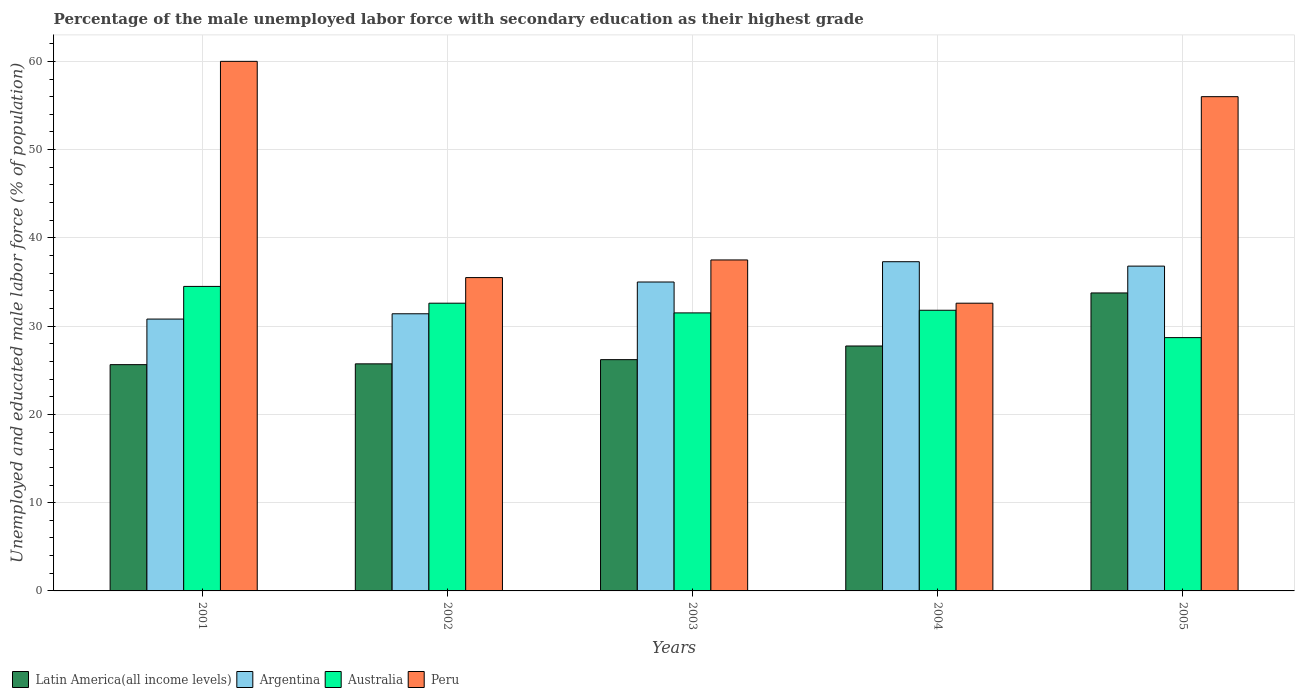How many groups of bars are there?
Offer a terse response. 5. How many bars are there on the 5th tick from the right?
Offer a very short reply. 4. What is the percentage of the unemployed male labor force with secondary education in Argentina in 2003?
Give a very brief answer. 35. Across all years, what is the maximum percentage of the unemployed male labor force with secondary education in Latin America(all income levels)?
Ensure brevity in your answer.  33.76. Across all years, what is the minimum percentage of the unemployed male labor force with secondary education in Argentina?
Your answer should be very brief. 30.8. In which year was the percentage of the unemployed male labor force with secondary education in Australia minimum?
Provide a short and direct response. 2005. What is the total percentage of the unemployed male labor force with secondary education in Peru in the graph?
Provide a succinct answer. 221.6. What is the difference between the percentage of the unemployed male labor force with secondary education in Peru in 2003 and that in 2005?
Offer a very short reply. -18.5. What is the difference between the percentage of the unemployed male labor force with secondary education in Australia in 2003 and the percentage of the unemployed male labor force with secondary education in Peru in 2002?
Keep it short and to the point. -4. What is the average percentage of the unemployed male labor force with secondary education in Peru per year?
Ensure brevity in your answer.  44.32. In the year 2002, what is the difference between the percentage of the unemployed male labor force with secondary education in Peru and percentage of the unemployed male labor force with secondary education in Argentina?
Your response must be concise. 4.1. In how many years, is the percentage of the unemployed male labor force with secondary education in Peru greater than 8 %?
Keep it short and to the point. 5. What is the ratio of the percentage of the unemployed male labor force with secondary education in Peru in 2004 to that in 2005?
Your answer should be compact. 0.58. Is the percentage of the unemployed male labor force with secondary education in Peru in 2002 less than that in 2005?
Give a very brief answer. Yes. What is the difference between the highest and the second highest percentage of the unemployed male labor force with secondary education in Peru?
Keep it short and to the point. 4. What is the difference between the highest and the lowest percentage of the unemployed male labor force with secondary education in Australia?
Your answer should be very brief. 5.8. Is it the case that in every year, the sum of the percentage of the unemployed male labor force with secondary education in Australia and percentage of the unemployed male labor force with secondary education in Latin America(all income levels) is greater than the percentage of the unemployed male labor force with secondary education in Peru?
Your answer should be compact. Yes. What is the difference between two consecutive major ticks on the Y-axis?
Make the answer very short. 10. Does the graph contain grids?
Keep it short and to the point. Yes. How many legend labels are there?
Your answer should be compact. 4. What is the title of the graph?
Offer a terse response. Percentage of the male unemployed labor force with secondary education as their highest grade. Does "Somalia" appear as one of the legend labels in the graph?
Provide a short and direct response. No. What is the label or title of the Y-axis?
Make the answer very short. Unemployed and educated male labor force (% of population). What is the Unemployed and educated male labor force (% of population) in Latin America(all income levels) in 2001?
Your answer should be compact. 25.64. What is the Unemployed and educated male labor force (% of population) in Argentina in 2001?
Offer a terse response. 30.8. What is the Unemployed and educated male labor force (% of population) in Australia in 2001?
Provide a succinct answer. 34.5. What is the Unemployed and educated male labor force (% of population) of Latin America(all income levels) in 2002?
Offer a terse response. 25.73. What is the Unemployed and educated male labor force (% of population) of Argentina in 2002?
Make the answer very short. 31.4. What is the Unemployed and educated male labor force (% of population) in Australia in 2002?
Your response must be concise. 32.6. What is the Unemployed and educated male labor force (% of population) of Peru in 2002?
Offer a terse response. 35.5. What is the Unemployed and educated male labor force (% of population) in Latin America(all income levels) in 2003?
Give a very brief answer. 26.2. What is the Unemployed and educated male labor force (% of population) in Argentina in 2003?
Offer a terse response. 35. What is the Unemployed and educated male labor force (% of population) in Australia in 2003?
Offer a terse response. 31.5. What is the Unemployed and educated male labor force (% of population) of Peru in 2003?
Keep it short and to the point. 37.5. What is the Unemployed and educated male labor force (% of population) in Latin America(all income levels) in 2004?
Offer a very short reply. 27.75. What is the Unemployed and educated male labor force (% of population) in Argentina in 2004?
Your response must be concise. 37.3. What is the Unemployed and educated male labor force (% of population) in Australia in 2004?
Give a very brief answer. 31.8. What is the Unemployed and educated male labor force (% of population) in Peru in 2004?
Give a very brief answer. 32.6. What is the Unemployed and educated male labor force (% of population) of Latin America(all income levels) in 2005?
Your answer should be compact. 33.76. What is the Unemployed and educated male labor force (% of population) in Argentina in 2005?
Your answer should be very brief. 36.8. What is the Unemployed and educated male labor force (% of population) in Australia in 2005?
Your answer should be compact. 28.7. What is the Unemployed and educated male labor force (% of population) in Peru in 2005?
Make the answer very short. 56. Across all years, what is the maximum Unemployed and educated male labor force (% of population) in Latin America(all income levels)?
Your answer should be very brief. 33.76. Across all years, what is the maximum Unemployed and educated male labor force (% of population) of Argentina?
Your answer should be compact. 37.3. Across all years, what is the maximum Unemployed and educated male labor force (% of population) in Australia?
Your answer should be very brief. 34.5. Across all years, what is the minimum Unemployed and educated male labor force (% of population) of Latin America(all income levels)?
Your answer should be very brief. 25.64. Across all years, what is the minimum Unemployed and educated male labor force (% of population) of Argentina?
Your response must be concise. 30.8. Across all years, what is the minimum Unemployed and educated male labor force (% of population) of Australia?
Offer a very short reply. 28.7. Across all years, what is the minimum Unemployed and educated male labor force (% of population) of Peru?
Offer a terse response. 32.6. What is the total Unemployed and educated male labor force (% of population) of Latin America(all income levels) in the graph?
Provide a succinct answer. 139.08. What is the total Unemployed and educated male labor force (% of population) in Argentina in the graph?
Provide a succinct answer. 171.3. What is the total Unemployed and educated male labor force (% of population) of Australia in the graph?
Ensure brevity in your answer.  159.1. What is the total Unemployed and educated male labor force (% of population) of Peru in the graph?
Keep it short and to the point. 221.6. What is the difference between the Unemployed and educated male labor force (% of population) of Latin America(all income levels) in 2001 and that in 2002?
Your response must be concise. -0.09. What is the difference between the Unemployed and educated male labor force (% of population) of Argentina in 2001 and that in 2002?
Provide a short and direct response. -0.6. What is the difference between the Unemployed and educated male labor force (% of population) of Australia in 2001 and that in 2002?
Give a very brief answer. 1.9. What is the difference between the Unemployed and educated male labor force (% of population) of Peru in 2001 and that in 2002?
Your response must be concise. 24.5. What is the difference between the Unemployed and educated male labor force (% of population) in Latin America(all income levels) in 2001 and that in 2003?
Your answer should be very brief. -0.57. What is the difference between the Unemployed and educated male labor force (% of population) of Argentina in 2001 and that in 2003?
Your response must be concise. -4.2. What is the difference between the Unemployed and educated male labor force (% of population) of Australia in 2001 and that in 2003?
Your response must be concise. 3. What is the difference between the Unemployed and educated male labor force (% of population) in Peru in 2001 and that in 2003?
Provide a succinct answer. 22.5. What is the difference between the Unemployed and educated male labor force (% of population) of Latin America(all income levels) in 2001 and that in 2004?
Keep it short and to the point. -2.11. What is the difference between the Unemployed and educated male labor force (% of population) in Argentina in 2001 and that in 2004?
Provide a succinct answer. -6.5. What is the difference between the Unemployed and educated male labor force (% of population) of Australia in 2001 and that in 2004?
Offer a very short reply. 2.7. What is the difference between the Unemployed and educated male labor force (% of population) of Peru in 2001 and that in 2004?
Your answer should be very brief. 27.4. What is the difference between the Unemployed and educated male labor force (% of population) of Latin America(all income levels) in 2001 and that in 2005?
Provide a succinct answer. -8.12. What is the difference between the Unemployed and educated male labor force (% of population) in Australia in 2001 and that in 2005?
Offer a very short reply. 5.8. What is the difference between the Unemployed and educated male labor force (% of population) in Latin America(all income levels) in 2002 and that in 2003?
Offer a terse response. -0.48. What is the difference between the Unemployed and educated male labor force (% of population) of Argentina in 2002 and that in 2003?
Provide a short and direct response. -3.6. What is the difference between the Unemployed and educated male labor force (% of population) in Peru in 2002 and that in 2003?
Make the answer very short. -2. What is the difference between the Unemployed and educated male labor force (% of population) of Latin America(all income levels) in 2002 and that in 2004?
Your response must be concise. -2.02. What is the difference between the Unemployed and educated male labor force (% of population) in Australia in 2002 and that in 2004?
Provide a short and direct response. 0.8. What is the difference between the Unemployed and educated male labor force (% of population) of Latin America(all income levels) in 2002 and that in 2005?
Give a very brief answer. -8.03. What is the difference between the Unemployed and educated male labor force (% of population) in Peru in 2002 and that in 2005?
Provide a succinct answer. -20.5. What is the difference between the Unemployed and educated male labor force (% of population) in Latin America(all income levels) in 2003 and that in 2004?
Offer a very short reply. -1.55. What is the difference between the Unemployed and educated male labor force (% of population) of Peru in 2003 and that in 2004?
Keep it short and to the point. 4.9. What is the difference between the Unemployed and educated male labor force (% of population) of Latin America(all income levels) in 2003 and that in 2005?
Your answer should be very brief. -7.56. What is the difference between the Unemployed and educated male labor force (% of population) of Peru in 2003 and that in 2005?
Your answer should be compact. -18.5. What is the difference between the Unemployed and educated male labor force (% of population) in Latin America(all income levels) in 2004 and that in 2005?
Keep it short and to the point. -6.01. What is the difference between the Unemployed and educated male labor force (% of population) of Argentina in 2004 and that in 2005?
Your answer should be very brief. 0.5. What is the difference between the Unemployed and educated male labor force (% of population) in Australia in 2004 and that in 2005?
Offer a very short reply. 3.1. What is the difference between the Unemployed and educated male labor force (% of population) of Peru in 2004 and that in 2005?
Provide a short and direct response. -23.4. What is the difference between the Unemployed and educated male labor force (% of population) in Latin America(all income levels) in 2001 and the Unemployed and educated male labor force (% of population) in Argentina in 2002?
Provide a short and direct response. -5.76. What is the difference between the Unemployed and educated male labor force (% of population) of Latin America(all income levels) in 2001 and the Unemployed and educated male labor force (% of population) of Australia in 2002?
Offer a terse response. -6.96. What is the difference between the Unemployed and educated male labor force (% of population) of Latin America(all income levels) in 2001 and the Unemployed and educated male labor force (% of population) of Peru in 2002?
Ensure brevity in your answer.  -9.86. What is the difference between the Unemployed and educated male labor force (% of population) in Argentina in 2001 and the Unemployed and educated male labor force (% of population) in Australia in 2002?
Offer a terse response. -1.8. What is the difference between the Unemployed and educated male labor force (% of population) in Australia in 2001 and the Unemployed and educated male labor force (% of population) in Peru in 2002?
Your answer should be compact. -1. What is the difference between the Unemployed and educated male labor force (% of population) in Latin America(all income levels) in 2001 and the Unemployed and educated male labor force (% of population) in Argentina in 2003?
Ensure brevity in your answer.  -9.36. What is the difference between the Unemployed and educated male labor force (% of population) of Latin America(all income levels) in 2001 and the Unemployed and educated male labor force (% of population) of Australia in 2003?
Provide a short and direct response. -5.86. What is the difference between the Unemployed and educated male labor force (% of population) of Latin America(all income levels) in 2001 and the Unemployed and educated male labor force (% of population) of Peru in 2003?
Your response must be concise. -11.86. What is the difference between the Unemployed and educated male labor force (% of population) in Argentina in 2001 and the Unemployed and educated male labor force (% of population) in Peru in 2003?
Keep it short and to the point. -6.7. What is the difference between the Unemployed and educated male labor force (% of population) of Latin America(all income levels) in 2001 and the Unemployed and educated male labor force (% of population) of Argentina in 2004?
Give a very brief answer. -11.66. What is the difference between the Unemployed and educated male labor force (% of population) of Latin America(all income levels) in 2001 and the Unemployed and educated male labor force (% of population) of Australia in 2004?
Provide a short and direct response. -6.16. What is the difference between the Unemployed and educated male labor force (% of population) in Latin America(all income levels) in 2001 and the Unemployed and educated male labor force (% of population) in Peru in 2004?
Provide a succinct answer. -6.96. What is the difference between the Unemployed and educated male labor force (% of population) of Argentina in 2001 and the Unemployed and educated male labor force (% of population) of Australia in 2004?
Give a very brief answer. -1. What is the difference between the Unemployed and educated male labor force (% of population) in Argentina in 2001 and the Unemployed and educated male labor force (% of population) in Peru in 2004?
Provide a short and direct response. -1.8. What is the difference between the Unemployed and educated male labor force (% of population) of Latin America(all income levels) in 2001 and the Unemployed and educated male labor force (% of population) of Argentina in 2005?
Keep it short and to the point. -11.16. What is the difference between the Unemployed and educated male labor force (% of population) of Latin America(all income levels) in 2001 and the Unemployed and educated male labor force (% of population) of Australia in 2005?
Provide a short and direct response. -3.06. What is the difference between the Unemployed and educated male labor force (% of population) in Latin America(all income levels) in 2001 and the Unemployed and educated male labor force (% of population) in Peru in 2005?
Your response must be concise. -30.36. What is the difference between the Unemployed and educated male labor force (% of population) in Argentina in 2001 and the Unemployed and educated male labor force (% of population) in Peru in 2005?
Your response must be concise. -25.2. What is the difference between the Unemployed and educated male labor force (% of population) of Australia in 2001 and the Unemployed and educated male labor force (% of population) of Peru in 2005?
Provide a short and direct response. -21.5. What is the difference between the Unemployed and educated male labor force (% of population) of Latin America(all income levels) in 2002 and the Unemployed and educated male labor force (% of population) of Argentina in 2003?
Offer a terse response. -9.27. What is the difference between the Unemployed and educated male labor force (% of population) of Latin America(all income levels) in 2002 and the Unemployed and educated male labor force (% of population) of Australia in 2003?
Provide a short and direct response. -5.77. What is the difference between the Unemployed and educated male labor force (% of population) in Latin America(all income levels) in 2002 and the Unemployed and educated male labor force (% of population) in Peru in 2003?
Offer a very short reply. -11.77. What is the difference between the Unemployed and educated male labor force (% of population) of Australia in 2002 and the Unemployed and educated male labor force (% of population) of Peru in 2003?
Keep it short and to the point. -4.9. What is the difference between the Unemployed and educated male labor force (% of population) in Latin America(all income levels) in 2002 and the Unemployed and educated male labor force (% of population) in Argentina in 2004?
Keep it short and to the point. -11.57. What is the difference between the Unemployed and educated male labor force (% of population) of Latin America(all income levels) in 2002 and the Unemployed and educated male labor force (% of population) of Australia in 2004?
Make the answer very short. -6.07. What is the difference between the Unemployed and educated male labor force (% of population) in Latin America(all income levels) in 2002 and the Unemployed and educated male labor force (% of population) in Peru in 2004?
Your response must be concise. -6.87. What is the difference between the Unemployed and educated male labor force (% of population) of Argentina in 2002 and the Unemployed and educated male labor force (% of population) of Australia in 2004?
Give a very brief answer. -0.4. What is the difference between the Unemployed and educated male labor force (% of population) of Australia in 2002 and the Unemployed and educated male labor force (% of population) of Peru in 2004?
Ensure brevity in your answer.  0. What is the difference between the Unemployed and educated male labor force (% of population) in Latin America(all income levels) in 2002 and the Unemployed and educated male labor force (% of population) in Argentina in 2005?
Make the answer very short. -11.07. What is the difference between the Unemployed and educated male labor force (% of population) in Latin America(all income levels) in 2002 and the Unemployed and educated male labor force (% of population) in Australia in 2005?
Offer a very short reply. -2.97. What is the difference between the Unemployed and educated male labor force (% of population) in Latin America(all income levels) in 2002 and the Unemployed and educated male labor force (% of population) in Peru in 2005?
Make the answer very short. -30.27. What is the difference between the Unemployed and educated male labor force (% of population) of Argentina in 2002 and the Unemployed and educated male labor force (% of population) of Peru in 2005?
Make the answer very short. -24.6. What is the difference between the Unemployed and educated male labor force (% of population) in Australia in 2002 and the Unemployed and educated male labor force (% of population) in Peru in 2005?
Provide a short and direct response. -23.4. What is the difference between the Unemployed and educated male labor force (% of population) of Latin America(all income levels) in 2003 and the Unemployed and educated male labor force (% of population) of Argentina in 2004?
Your answer should be compact. -11.1. What is the difference between the Unemployed and educated male labor force (% of population) of Latin America(all income levels) in 2003 and the Unemployed and educated male labor force (% of population) of Australia in 2004?
Your response must be concise. -5.6. What is the difference between the Unemployed and educated male labor force (% of population) in Latin America(all income levels) in 2003 and the Unemployed and educated male labor force (% of population) in Peru in 2004?
Your answer should be very brief. -6.4. What is the difference between the Unemployed and educated male labor force (% of population) in Latin America(all income levels) in 2003 and the Unemployed and educated male labor force (% of population) in Argentina in 2005?
Keep it short and to the point. -10.6. What is the difference between the Unemployed and educated male labor force (% of population) of Latin America(all income levels) in 2003 and the Unemployed and educated male labor force (% of population) of Australia in 2005?
Give a very brief answer. -2.5. What is the difference between the Unemployed and educated male labor force (% of population) in Latin America(all income levels) in 2003 and the Unemployed and educated male labor force (% of population) in Peru in 2005?
Keep it short and to the point. -29.8. What is the difference between the Unemployed and educated male labor force (% of population) of Argentina in 2003 and the Unemployed and educated male labor force (% of population) of Australia in 2005?
Provide a short and direct response. 6.3. What is the difference between the Unemployed and educated male labor force (% of population) in Australia in 2003 and the Unemployed and educated male labor force (% of population) in Peru in 2005?
Your answer should be compact. -24.5. What is the difference between the Unemployed and educated male labor force (% of population) of Latin America(all income levels) in 2004 and the Unemployed and educated male labor force (% of population) of Argentina in 2005?
Offer a very short reply. -9.05. What is the difference between the Unemployed and educated male labor force (% of population) of Latin America(all income levels) in 2004 and the Unemployed and educated male labor force (% of population) of Australia in 2005?
Ensure brevity in your answer.  -0.95. What is the difference between the Unemployed and educated male labor force (% of population) in Latin America(all income levels) in 2004 and the Unemployed and educated male labor force (% of population) in Peru in 2005?
Ensure brevity in your answer.  -28.25. What is the difference between the Unemployed and educated male labor force (% of population) of Argentina in 2004 and the Unemployed and educated male labor force (% of population) of Peru in 2005?
Give a very brief answer. -18.7. What is the difference between the Unemployed and educated male labor force (% of population) of Australia in 2004 and the Unemployed and educated male labor force (% of population) of Peru in 2005?
Your answer should be compact. -24.2. What is the average Unemployed and educated male labor force (% of population) in Latin America(all income levels) per year?
Make the answer very short. 27.82. What is the average Unemployed and educated male labor force (% of population) in Argentina per year?
Your response must be concise. 34.26. What is the average Unemployed and educated male labor force (% of population) in Australia per year?
Offer a terse response. 31.82. What is the average Unemployed and educated male labor force (% of population) in Peru per year?
Provide a short and direct response. 44.32. In the year 2001, what is the difference between the Unemployed and educated male labor force (% of population) of Latin America(all income levels) and Unemployed and educated male labor force (% of population) of Argentina?
Offer a terse response. -5.16. In the year 2001, what is the difference between the Unemployed and educated male labor force (% of population) of Latin America(all income levels) and Unemployed and educated male labor force (% of population) of Australia?
Make the answer very short. -8.86. In the year 2001, what is the difference between the Unemployed and educated male labor force (% of population) of Latin America(all income levels) and Unemployed and educated male labor force (% of population) of Peru?
Your answer should be compact. -34.36. In the year 2001, what is the difference between the Unemployed and educated male labor force (% of population) in Argentina and Unemployed and educated male labor force (% of population) in Peru?
Your answer should be compact. -29.2. In the year 2001, what is the difference between the Unemployed and educated male labor force (% of population) of Australia and Unemployed and educated male labor force (% of population) of Peru?
Your answer should be very brief. -25.5. In the year 2002, what is the difference between the Unemployed and educated male labor force (% of population) of Latin America(all income levels) and Unemployed and educated male labor force (% of population) of Argentina?
Your response must be concise. -5.67. In the year 2002, what is the difference between the Unemployed and educated male labor force (% of population) of Latin America(all income levels) and Unemployed and educated male labor force (% of population) of Australia?
Keep it short and to the point. -6.87. In the year 2002, what is the difference between the Unemployed and educated male labor force (% of population) of Latin America(all income levels) and Unemployed and educated male labor force (% of population) of Peru?
Make the answer very short. -9.77. In the year 2002, what is the difference between the Unemployed and educated male labor force (% of population) of Argentina and Unemployed and educated male labor force (% of population) of Australia?
Offer a terse response. -1.2. In the year 2003, what is the difference between the Unemployed and educated male labor force (% of population) in Latin America(all income levels) and Unemployed and educated male labor force (% of population) in Argentina?
Your answer should be compact. -8.8. In the year 2003, what is the difference between the Unemployed and educated male labor force (% of population) of Latin America(all income levels) and Unemployed and educated male labor force (% of population) of Australia?
Make the answer very short. -5.3. In the year 2003, what is the difference between the Unemployed and educated male labor force (% of population) in Latin America(all income levels) and Unemployed and educated male labor force (% of population) in Peru?
Your answer should be very brief. -11.3. In the year 2003, what is the difference between the Unemployed and educated male labor force (% of population) of Argentina and Unemployed and educated male labor force (% of population) of Australia?
Make the answer very short. 3.5. In the year 2003, what is the difference between the Unemployed and educated male labor force (% of population) in Argentina and Unemployed and educated male labor force (% of population) in Peru?
Offer a very short reply. -2.5. In the year 2004, what is the difference between the Unemployed and educated male labor force (% of population) in Latin America(all income levels) and Unemployed and educated male labor force (% of population) in Argentina?
Your answer should be very brief. -9.55. In the year 2004, what is the difference between the Unemployed and educated male labor force (% of population) in Latin America(all income levels) and Unemployed and educated male labor force (% of population) in Australia?
Give a very brief answer. -4.05. In the year 2004, what is the difference between the Unemployed and educated male labor force (% of population) in Latin America(all income levels) and Unemployed and educated male labor force (% of population) in Peru?
Your answer should be very brief. -4.85. In the year 2004, what is the difference between the Unemployed and educated male labor force (% of population) in Argentina and Unemployed and educated male labor force (% of population) in Australia?
Give a very brief answer. 5.5. In the year 2004, what is the difference between the Unemployed and educated male labor force (% of population) of Argentina and Unemployed and educated male labor force (% of population) of Peru?
Offer a terse response. 4.7. In the year 2005, what is the difference between the Unemployed and educated male labor force (% of population) of Latin America(all income levels) and Unemployed and educated male labor force (% of population) of Argentina?
Offer a very short reply. -3.04. In the year 2005, what is the difference between the Unemployed and educated male labor force (% of population) in Latin America(all income levels) and Unemployed and educated male labor force (% of population) in Australia?
Offer a terse response. 5.06. In the year 2005, what is the difference between the Unemployed and educated male labor force (% of population) of Latin America(all income levels) and Unemployed and educated male labor force (% of population) of Peru?
Give a very brief answer. -22.24. In the year 2005, what is the difference between the Unemployed and educated male labor force (% of population) of Argentina and Unemployed and educated male labor force (% of population) of Peru?
Your response must be concise. -19.2. In the year 2005, what is the difference between the Unemployed and educated male labor force (% of population) in Australia and Unemployed and educated male labor force (% of population) in Peru?
Your response must be concise. -27.3. What is the ratio of the Unemployed and educated male labor force (% of population) of Argentina in 2001 to that in 2002?
Your response must be concise. 0.98. What is the ratio of the Unemployed and educated male labor force (% of population) of Australia in 2001 to that in 2002?
Your answer should be very brief. 1.06. What is the ratio of the Unemployed and educated male labor force (% of population) of Peru in 2001 to that in 2002?
Make the answer very short. 1.69. What is the ratio of the Unemployed and educated male labor force (% of population) of Latin America(all income levels) in 2001 to that in 2003?
Make the answer very short. 0.98. What is the ratio of the Unemployed and educated male labor force (% of population) of Australia in 2001 to that in 2003?
Your response must be concise. 1.1. What is the ratio of the Unemployed and educated male labor force (% of population) of Latin America(all income levels) in 2001 to that in 2004?
Provide a succinct answer. 0.92. What is the ratio of the Unemployed and educated male labor force (% of population) in Argentina in 2001 to that in 2004?
Give a very brief answer. 0.83. What is the ratio of the Unemployed and educated male labor force (% of population) in Australia in 2001 to that in 2004?
Ensure brevity in your answer.  1.08. What is the ratio of the Unemployed and educated male labor force (% of population) in Peru in 2001 to that in 2004?
Your answer should be very brief. 1.84. What is the ratio of the Unemployed and educated male labor force (% of population) of Latin America(all income levels) in 2001 to that in 2005?
Your answer should be very brief. 0.76. What is the ratio of the Unemployed and educated male labor force (% of population) of Argentina in 2001 to that in 2005?
Offer a terse response. 0.84. What is the ratio of the Unemployed and educated male labor force (% of population) of Australia in 2001 to that in 2005?
Make the answer very short. 1.2. What is the ratio of the Unemployed and educated male labor force (% of population) of Peru in 2001 to that in 2005?
Your answer should be very brief. 1.07. What is the ratio of the Unemployed and educated male labor force (% of population) of Latin America(all income levels) in 2002 to that in 2003?
Ensure brevity in your answer.  0.98. What is the ratio of the Unemployed and educated male labor force (% of population) in Argentina in 2002 to that in 2003?
Your response must be concise. 0.9. What is the ratio of the Unemployed and educated male labor force (% of population) in Australia in 2002 to that in 2003?
Provide a short and direct response. 1.03. What is the ratio of the Unemployed and educated male labor force (% of population) of Peru in 2002 to that in 2003?
Ensure brevity in your answer.  0.95. What is the ratio of the Unemployed and educated male labor force (% of population) in Latin America(all income levels) in 2002 to that in 2004?
Give a very brief answer. 0.93. What is the ratio of the Unemployed and educated male labor force (% of population) of Argentina in 2002 to that in 2004?
Ensure brevity in your answer.  0.84. What is the ratio of the Unemployed and educated male labor force (% of population) of Australia in 2002 to that in 2004?
Make the answer very short. 1.03. What is the ratio of the Unemployed and educated male labor force (% of population) of Peru in 2002 to that in 2004?
Offer a very short reply. 1.09. What is the ratio of the Unemployed and educated male labor force (% of population) in Latin America(all income levels) in 2002 to that in 2005?
Your response must be concise. 0.76. What is the ratio of the Unemployed and educated male labor force (% of population) of Argentina in 2002 to that in 2005?
Your answer should be compact. 0.85. What is the ratio of the Unemployed and educated male labor force (% of population) of Australia in 2002 to that in 2005?
Provide a succinct answer. 1.14. What is the ratio of the Unemployed and educated male labor force (% of population) of Peru in 2002 to that in 2005?
Keep it short and to the point. 0.63. What is the ratio of the Unemployed and educated male labor force (% of population) in Latin America(all income levels) in 2003 to that in 2004?
Provide a succinct answer. 0.94. What is the ratio of the Unemployed and educated male labor force (% of population) in Argentina in 2003 to that in 2004?
Your answer should be very brief. 0.94. What is the ratio of the Unemployed and educated male labor force (% of population) in Australia in 2003 to that in 2004?
Provide a short and direct response. 0.99. What is the ratio of the Unemployed and educated male labor force (% of population) of Peru in 2003 to that in 2004?
Your answer should be compact. 1.15. What is the ratio of the Unemployed and educated male labor force (% of population) of Latin America(all income levels) in 2003 to that in 2005?
Your response must be concise. 0.78. What is the ratio of the Unemployed and educated male labor force (% of population) in Argentina in 2003 to that in 2005?
Ensure brevity in your answer.  0.95. What is the ratio of the Unemployed and educated male labor force (% of population) of Australia in 2003 to that in 2005?
Offer a very short reply. 1.1. What is the ratio of the Unemployed and educated male labor force (% of population) in Peru in 2003 to that in 2005?
Provide a succinct answer. 0.67. What is the ratio of the Unemployed and educated male labor force (% of population) in Latin America(all income levels) in 2004 to that in 2005?
Ensure brevity in your answer.  0.82. What is the ratio of the Unemployed and educated male labor force (% of population) in Argentina in 2004 to that in 2005?
Your answer should be very brief. 1.01. What is the ratio of the Unemployed and educated male labor force (% of population) of Australia in 2004 to that in 2005?
Ensure brevity in your answer.  1.11. What is the ratio of the Unemployed and educated male labor force (% of population) of Peru in 2004 to that in 2005?
Provide a succinct answer. 0.58. What is the difference between the highest and the second highest Unemployed and educated male labor force (% of population) of Latin America(all income levels)?
Your answer should be very brief. 6.01. What is the difference between the highest and the second highest Unemployed and educated male labor force (% of population) in Argentina?
Offer a very short reply. 0.5. What is the difference between the highest and the second highest Unemployed and educated male labor force (% of population) in Australia?
Offer a very short reply. 1.9. What is the difference between the highest and the second highest Unemployed and educated male labor force (% of population) in Peru?
Make the answer very short. 4. What is the difference between the highest and the lowest Unemployed and educated male labor force (% of population) in Latin America(all income levels)?
Give a very brief answer. 8.12. What is the difference between the highest and the lowest Unemployed and educated male labor force (% of population) of Peru?
Offer a very short reply. 27.4. 